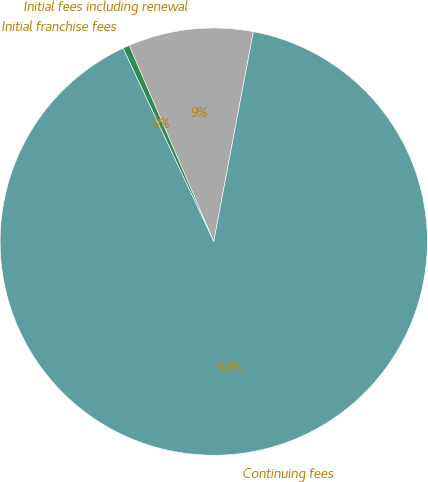Convert chart. <chart><loc_0><loc_0><loc_500><loc_500><pie_chart><fcel>Initial fees including renewal<fcel>Initial franchise fees<fcel>Continuing fees<nl><fcel>9.45%<fcel>0.5%<fcel>90.05%<nl></chart> 